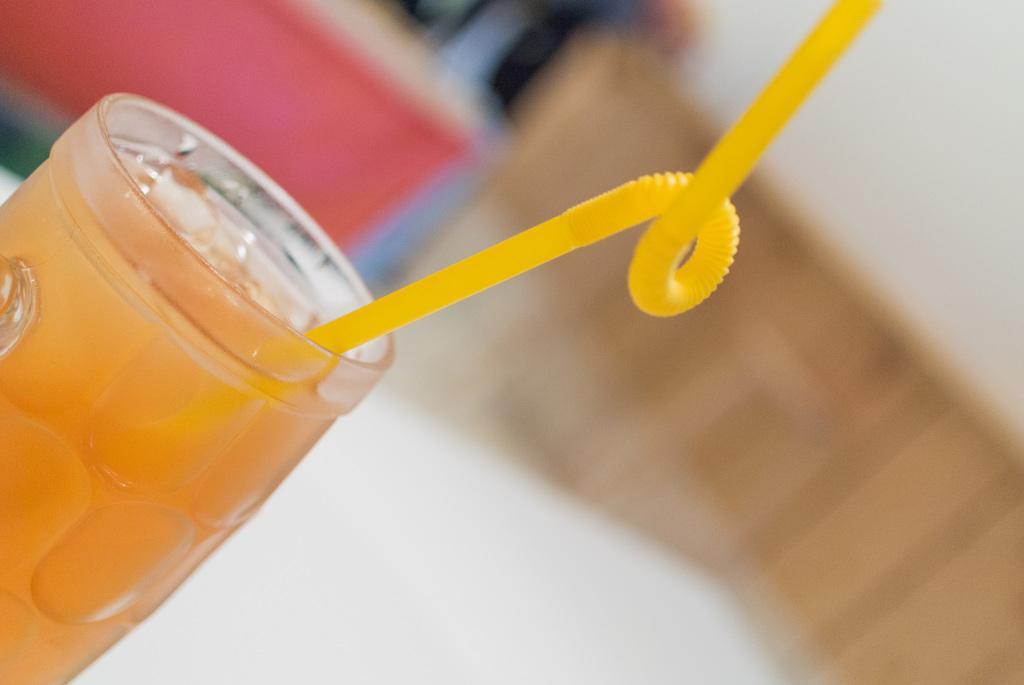Describe this image in one or two sentences. On the left side of the image we can see a glass containing a drink and there is a straw in it. 